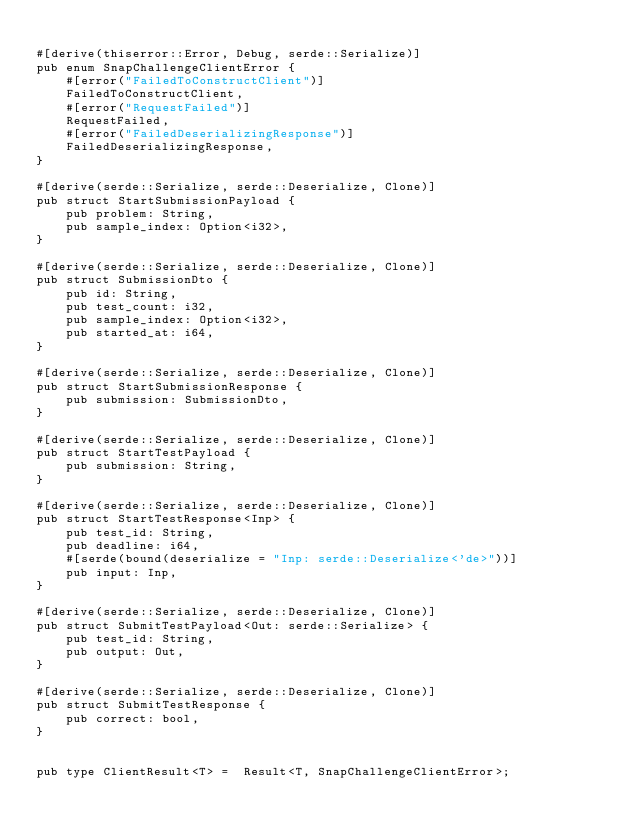<code> <loc_0><loc_0><loc_500><loc_500><_Rust_>
#[derive(thiserror::Error, Debug, serde::Serialize)]
pub enum SnapChallengeClientError {
    #[error("FailedToConstructClient")]
    FailedToConstructClient,
    #[error("RequestFailed")]
    RequestFailed,
    #[error("FailedDeserializingResponse")]
    FailedDeserializingResponse,
}

#[derive(serde::Serialize, serde::Deserialize, Clone)]
pub struct StartSubmissionPayload {
    pub problem: String,
    pub sample_index: Option<i32>,
}

#[derive(serde::Serialize, serde::Deserialize, Clone)]
pub struct SubmissionDto {
    pub id: String,
    pub test_count: i32,
    pub sample_index: Option<i32>,
    pub started_at: i64,
}

#[derive(serde::Serialize, serde::Deserialize, Clone)]
pub struct StartSubmissionResponse {
    pub submission: SubmissionDto,
}

#[derive(serde::Serialize, serde::Deserialize, Clone)]
pub struct StartTestPayload {
    pub submission: String,
}

#[derive(serde::Serialize, serde::Deserialize, Clone)]
pub struct StartTestResponse<Inp> {
    pub test_id: String,
    pub deadline: i64,
    #[serde(bound(deserialize = "Inp: serde::Deserialize<'de>"))]
    pub input: Inp,
}

#[derive(serde::Serialize, serde::Deserialize, Clone)]
pub struct SubmitTestPayload<Out: serde::Serialize> {
    pub test_id: String,
    pub output: Out,
}

#[derive(serde::Serialize, serde::Deserialize, Clone)]
pub struct SubmitTestResponse {
    pub correct: bool,
}


pub type ClientResult<T> =  Result<T, SnapChallengeClientError>;
</code> 